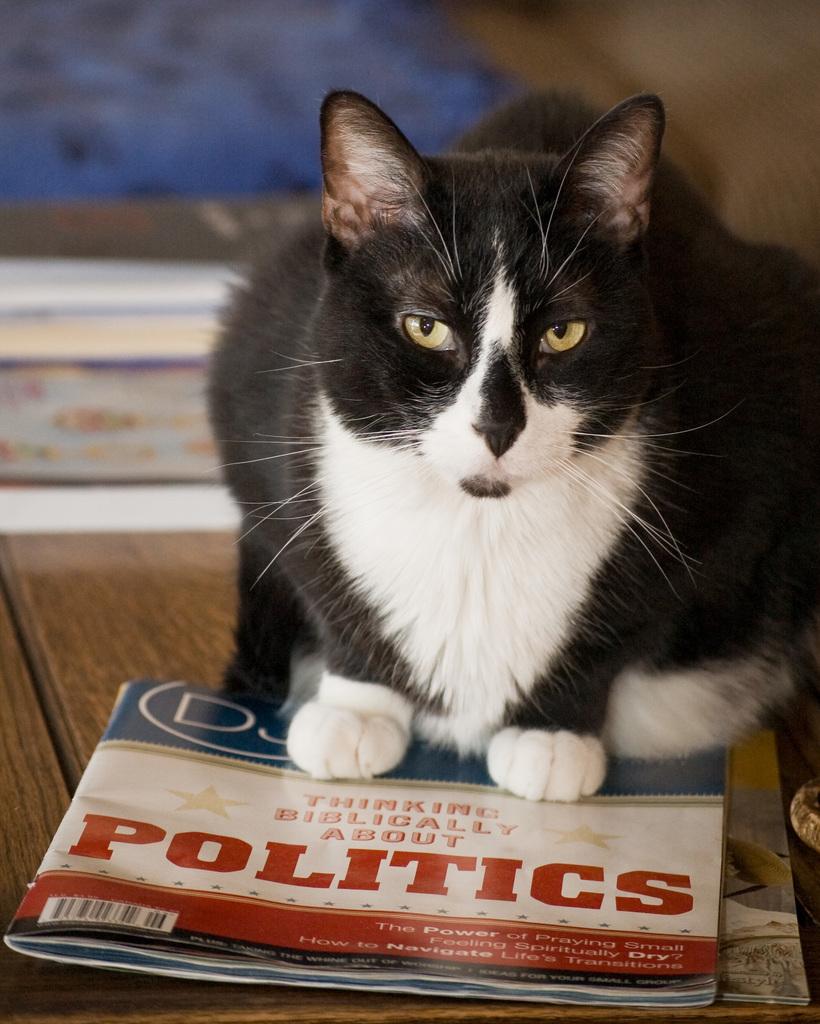What is the title of the article in the magazine?
Your response must be concise. Politics. 